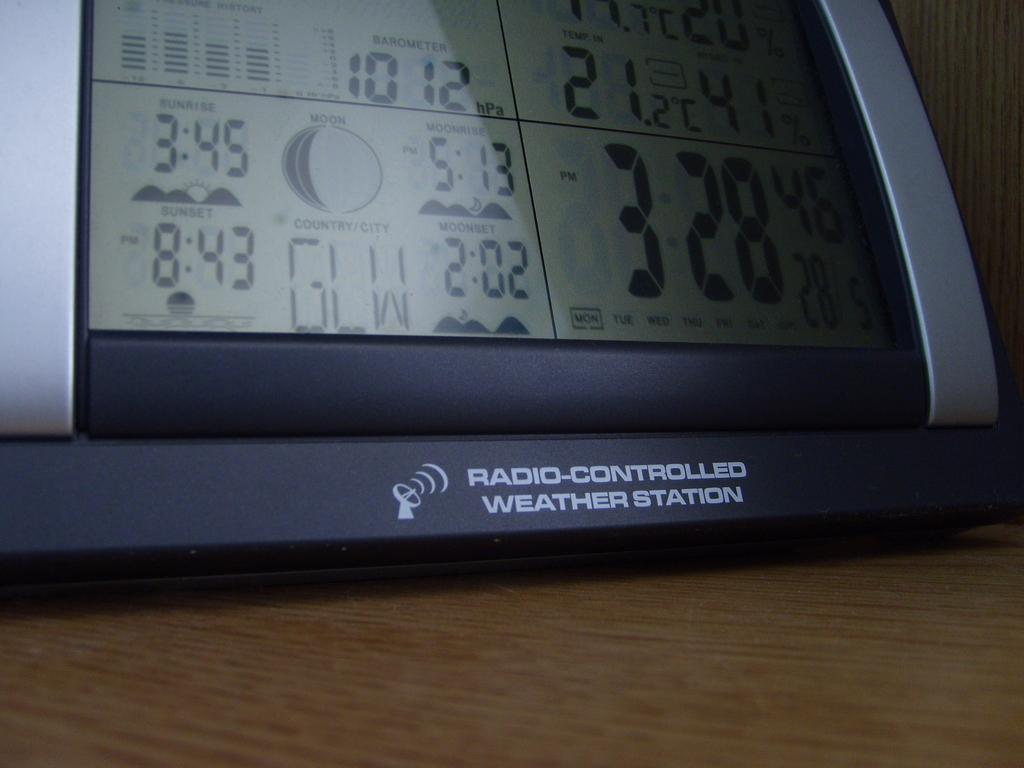<image>
Give a short and clear explanation of the subsequent image. a clock with moon phase and other weather data, the stand reading radio-controlled weather station 